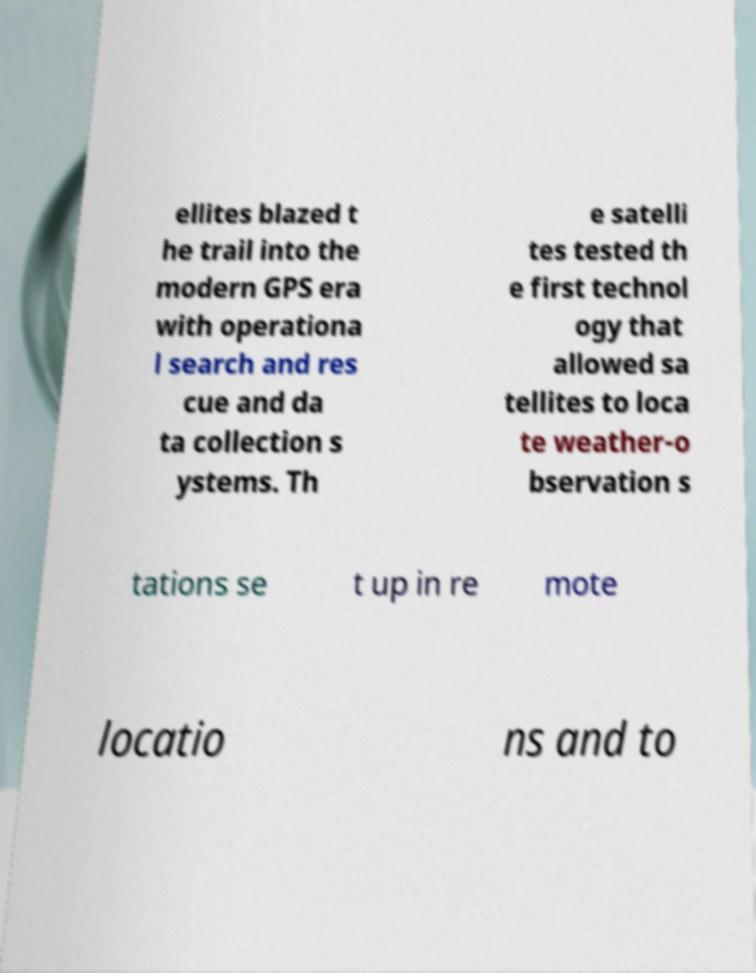What messages or text are displayed in this image? I need them in a readable, typed format. ellites blazed t he trail into the modern GPS era with operationa l search and res cue and da ta collection s ystems. Th e satelli tes tested th e first technol ogy that allowed sa tellites to loca te weather-o bservation s tations se t up in re mote locatio ns and to 